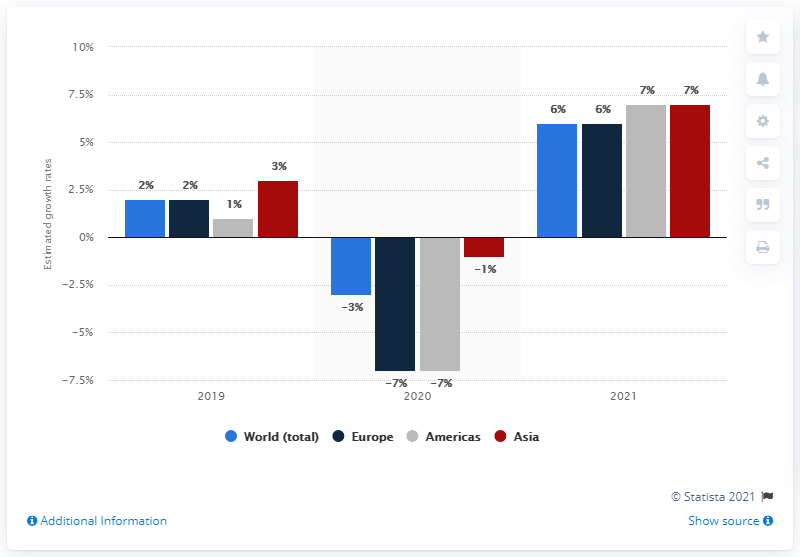Indicate a few pertinent items in this graphic. The electronics industry is anticipated to rebound from its downturn in 2020. 